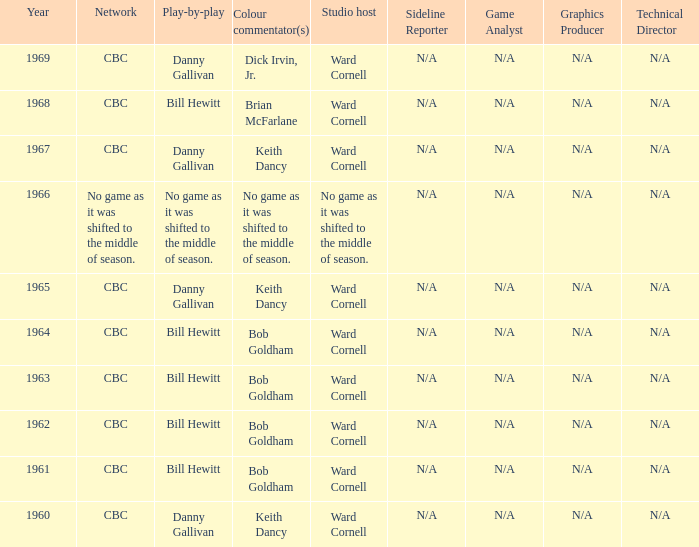I'm looking to parse the entire table for insights. Could you assist me with that? {'header': ['Year', 'Network', 'Play-by-play', 'Colour commentator(s)', 'Studio host', 'Sideline Reporter', 'Game Analyst', 'Graphics Producer', 'Technical Director'], 'rows': [['1969', 'CBC', 'Danny Gallivan', 'Dick Irvin, Jr.', 'Ward Cornell', 'N/A', 'N/A', 'N/A', 'N/A'], ['1968', 'CBC', 'Bill Hewitt', 'Brian McFarlane', 'Ward Cornell', 'N/A', 'N/A', 'N/A', 'N/A'], ['1967', 'CBC', 'Danny Gallivan', 'Keith Dancy', 'Ward Cornell', 'N/A', 'N/A', 'N/A', 'N/A'], ['1966', 'No game as it was shifted to the middle of season.', 'No game as it was shifted to the middle of season.', 'No game as it was shifted to the middle of season.', 'No game as it was shifted to the middle of season.', 'N/A', 'N/A', 'N/A', 'N/A'], ['1965', 'CBC', 'Danny Gallivan', 'Keith Dancy', 'Ward Cornell', 'N/A', 'N/A', 'N/A', 'N/A'], ['1964', 'CBC', 'Bill Hewitt', 'Bob Goldham', 'Ward Cornell', 'N/A', 'N/A', 'N/A', 'N/A'], ['1963', 'CBC', 'Bill Hewitt', 'Bob Goldham', 'Ward Cornell', 'N/A', 'N/A', 'N/A', 'N/A'], ['1962', 'CBC', 'Bill Hewitt', 'Bob Goldham', 'Ward Cornell', 'N/A', 'N/A', 'N/A', 'N/A'], ['1961', 'CBC', 'Bill Hewitt', 'Bob Goldham', 'Ward Cornell', 'N/A', 'N/A', 'N/A', 'N/A'], ['1960', 'CBC', 'Danny Gallivan', 'Keith Dancy', 'Ward Cornell', 'N/A', 'N/A', 'N/A', 'N/A']]} Were the color commentators who worked with Bill Hewitt doing the play-by-play? Brian McFarlane, Bob Goldham, Bob Goldham, Bob Goldham, Bob Goldham. 